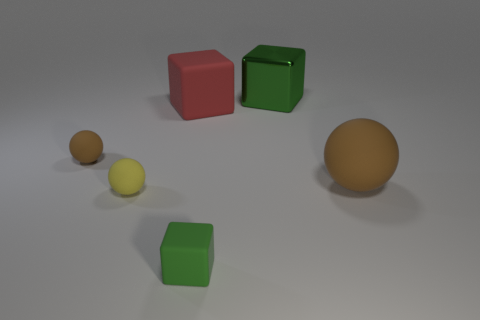Subtract all brown balls. How many green blocks are left? 2 Subtract all green cubes. How many cubes are left? 1 Add 4 small rubber cubes. How many objects exist? 10 Subtract 1 cubes. How many cubes are left? 2 Subtract all blue spheres. Subtract all blue blocks. How many spheres are left? 3 Subtract all green metallic things. Subtract all big brown objects. How many objects are left? 4 Add 2 green matte blocks. How many green matte blocks are left? 3 Add 5 small cyan metallic cubes. How many small cyan metallic cubes exist? 5 Subtract 0 cyan balls. How many objects are left? 6 